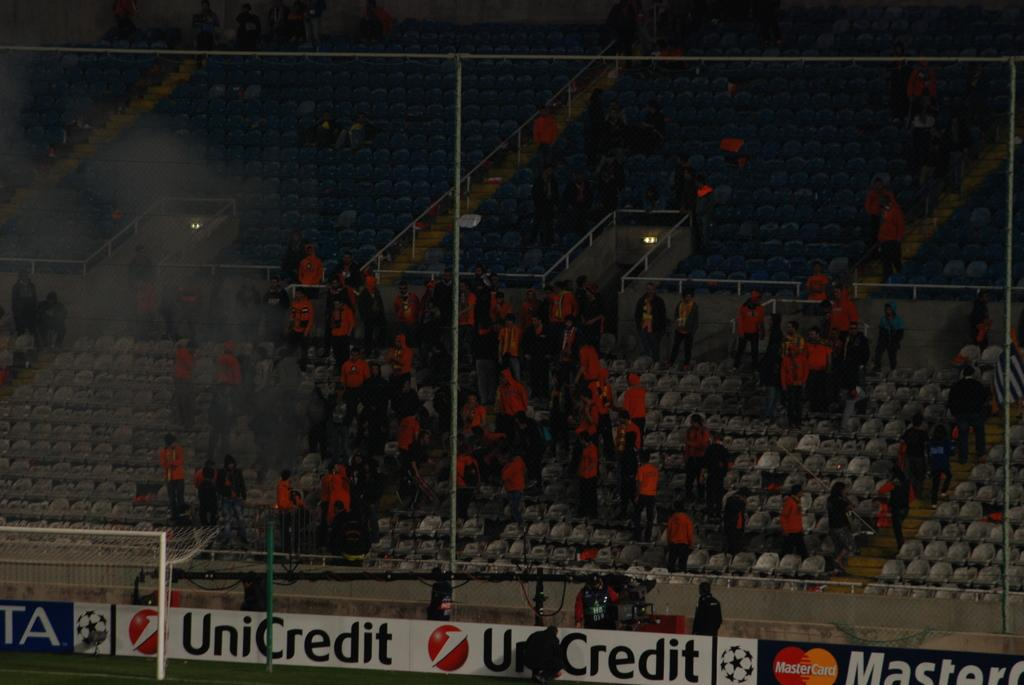<image>
Provide a brief description of the given image. A small number of people are in the stands at a stadium where UniCredit advertises. 